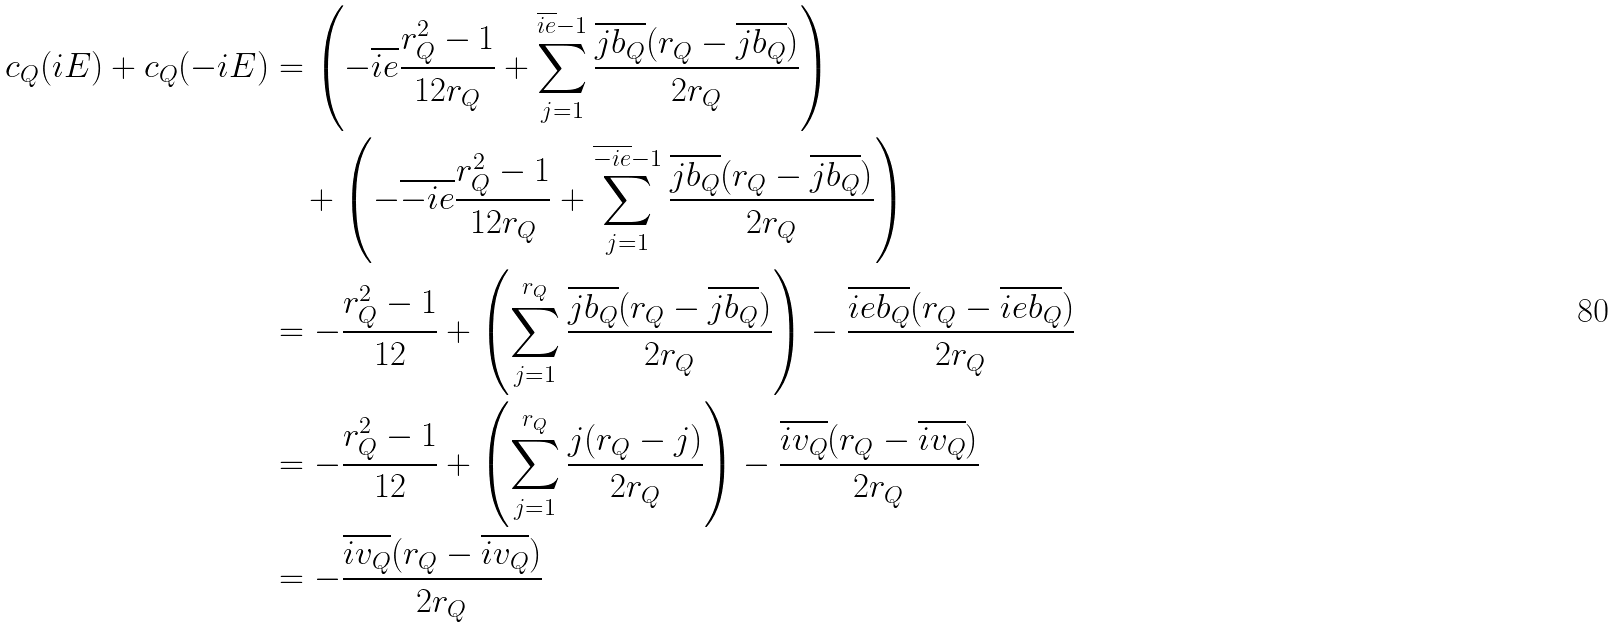Convert formula to latex. <formula><loc_0><loc_0><loc_500><loc_500>c _ { Q } ( i E ) + c _ { Q } ( - i E ) & = \left ( - \overline { i e } \frac { r _ { Q } ^ { 2 } - 1 } { 1 2 r _ { Q } } + \sum _ { j = 1 } ^ { \overline { i e } - 1 } \frac { \overline { j b _ { Q } } ( r _ { Q } - \overline { j b _ { Q } } ) } { 2 r _ { Q } } \right ) \\ & \quad + \left ( - \overline { - i e } \frac { r _ { Q } ^ { 2 } - 1 } { 1 2 r _ { Q } } + \sum _ { j = 1 } ^ { \overline { - i e } - 1 } \frac { \overline { j b _ { Q } } ( r _ { Q } - \overline { j b _ { Q } } ) } { 2 r _ { Q } } \right ) \\ & = - \frac { r _ { Q } ^ { 2 } - 1 } { 1 2 } + \left ( \sum _ { j = 1 } ^ { r _ { Q } } \frac { \overline { j b _ { Q } } ( r _ { Q } - \overline { j b _ { Q } } ) } { 2 r _ { Q } } \right ) - \frac { \overline { i e b _ { Q } } ( r _ { Q } - \overline { i e b _ { Q } } ) } { 2 r _ { Q } } \\ & = - \frac { r _ { Q } ^ { 2 } - 1 } { 1 2 } + \left ( \sum _ { j = 1 } ^ { r _ { Q } } \frac { j ( r _ { Q } - j ) } { 2 r _ { Q } } \right ) - \frac { \overline { i v _ { Q } } ( r _ { Q } - \overline { i v _ { Q } } ) } { 2 r _ { Q } } \\ & = - \frac { \overline { i v _ { Q } } ( r _ { Q } - \overline { i v _ { Q } } ) } { 2 r _ { Q } }</formula> 